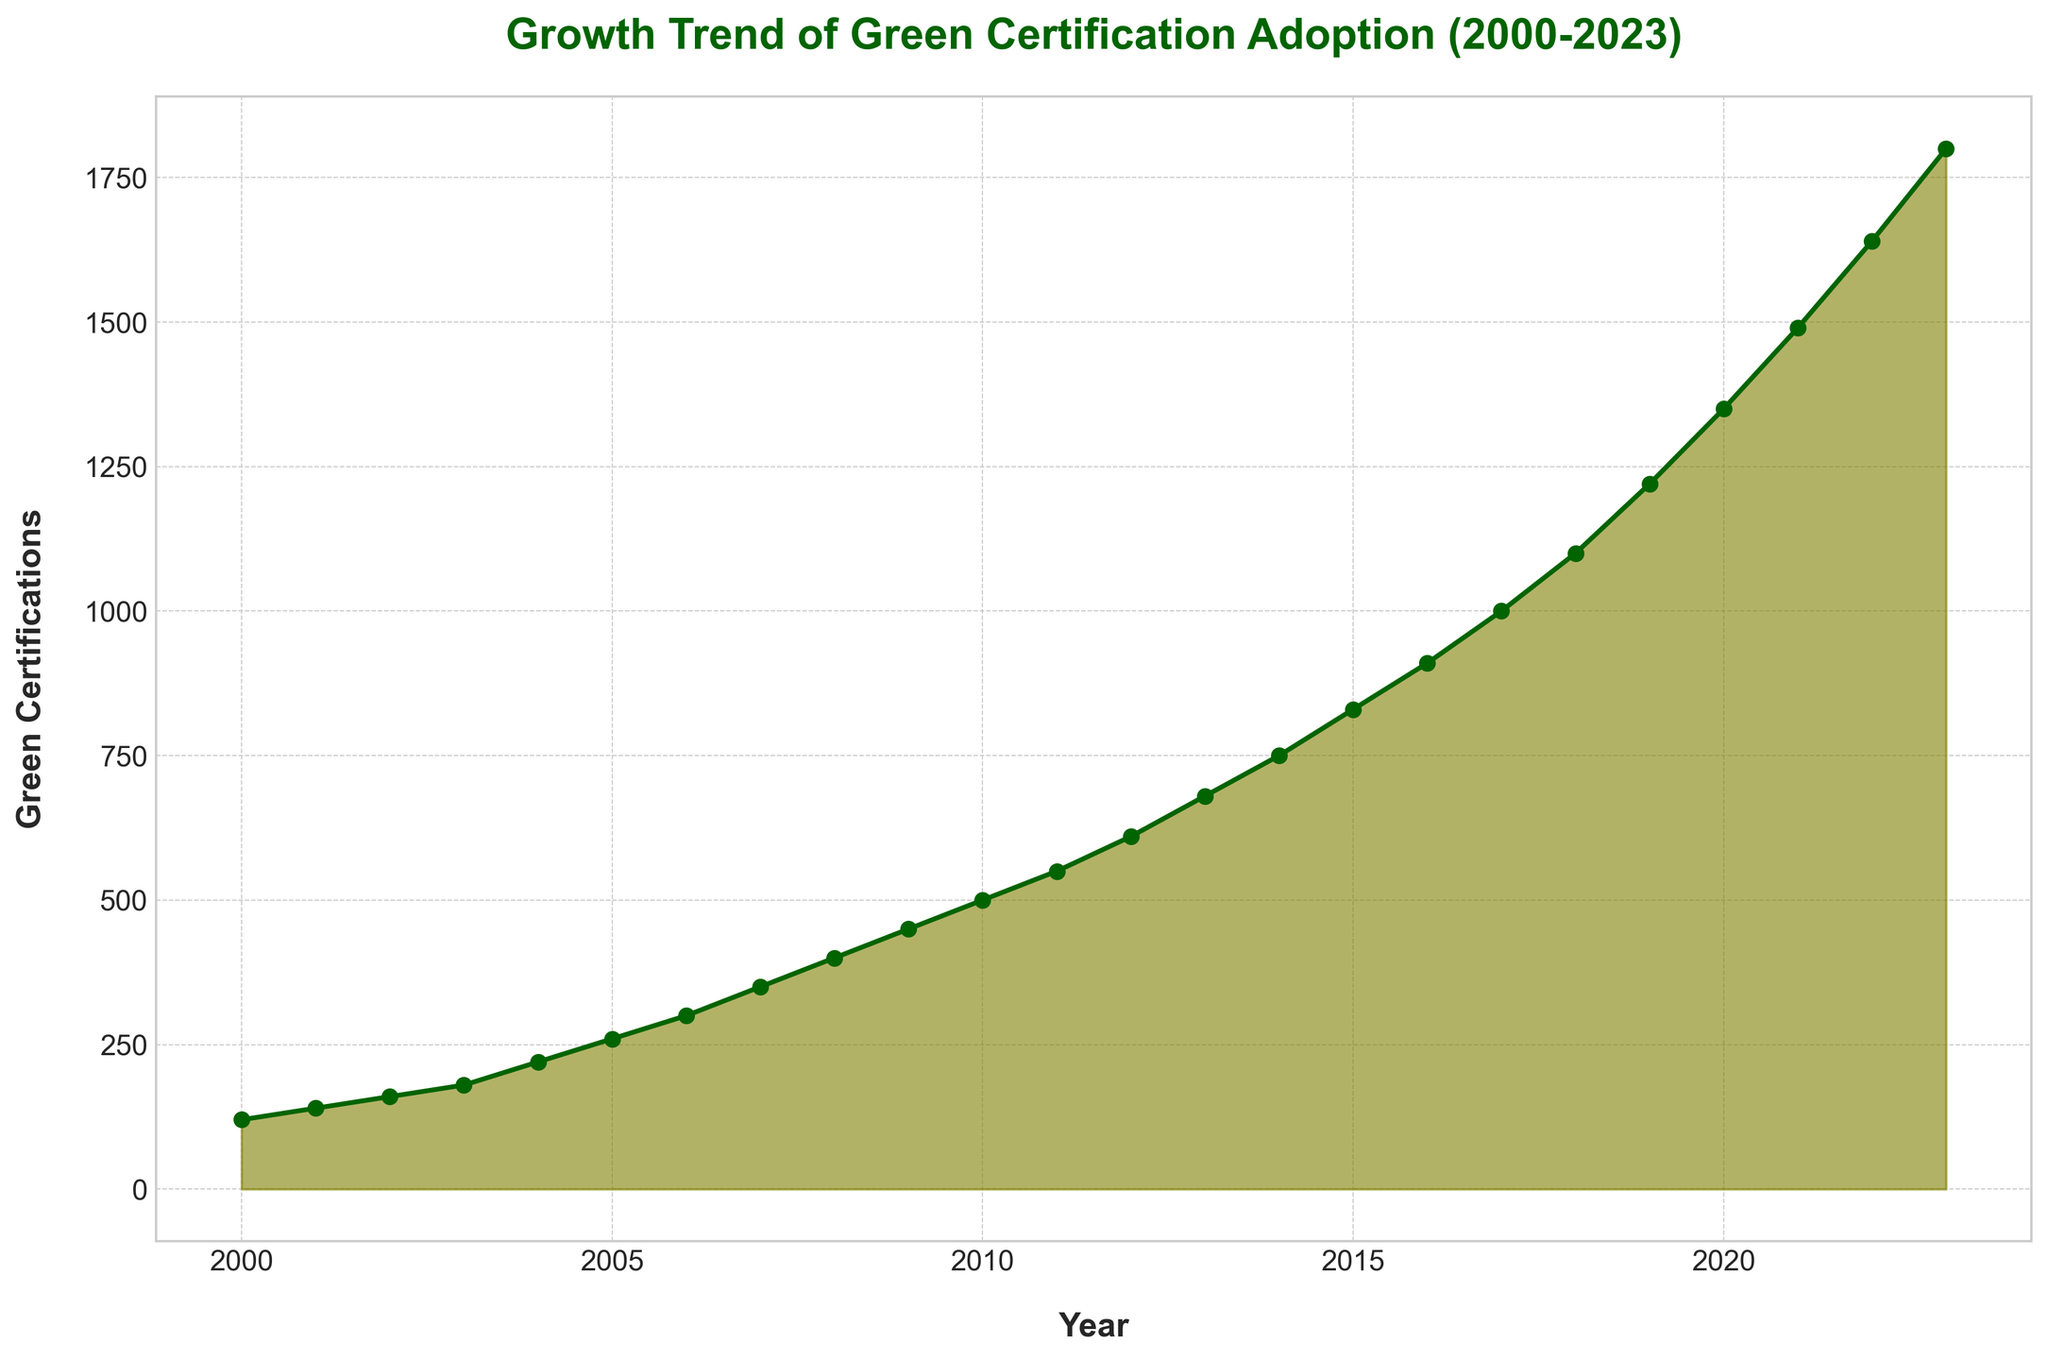What's the overall trend in the adoption of green certifications from 2000 to 2023? The figure shows an increasing trend with the number of certifications rising steadily each year from 120 in 2000 to 1800 in 2023.
Answer: Increasing Which year saw the highest number of green certifications? By examining the height of the filled area in the plot, 2023 has the highest number of green certifications, reaching 1800.
Answer: 2023 How much did the number of green certifications increase between 2010 and 2020? In 2010, the number was 500, and in 2020, it was 1350. The increase between these years is calculated as 1350 - 500.
Answer: 850 Compare the growth rate between the periods 2000-2010 and 2010-2020. Which period had a higher growth rate? From 2000 to 2010, certifications grew from 120 to 500 (380 increase). From 2010 to 2020, it grew from 500 to 1350 (850 increase). The second period saw a higher growth rate.
Answer: 2010-2020 What is the average number of green certifications per year from 2000 to 2023? Sum all the values from 2000 to 2023 and divide by the number of years (24). The total sum is (120 + 140 + 160 + ... + 1800) and dividing by 24 gives the average.
Answer: 717.5 In which year did the number of green certifications first exceed 1000? Checking the increasing trend, 2017 is the first year when the number of certifications surpassed 1000.
Answer: 2017 By how much did the number of green certifications grow from 2005 to 2015? In 2005, the number was 260, and in 2015, it was 830. The growth is calculated as 830 - 260.
Answer: 570 What is the difference in the number of green certifications between the years 2012 and 2023? The number of certifications in 2012 was 610 and in 2023 it was 1800. The difference is calculated as 1800 - 610.
Answer: 1190 What was the median number of green certifications between 2000 and 2023? To find the median, list all certification values in ascending order and find the middle value. With 24 data points, the median is the average of the 12th and 13th values.  These values are 550 and 610. So, (550 + 610) / 2.
Answer: 580 